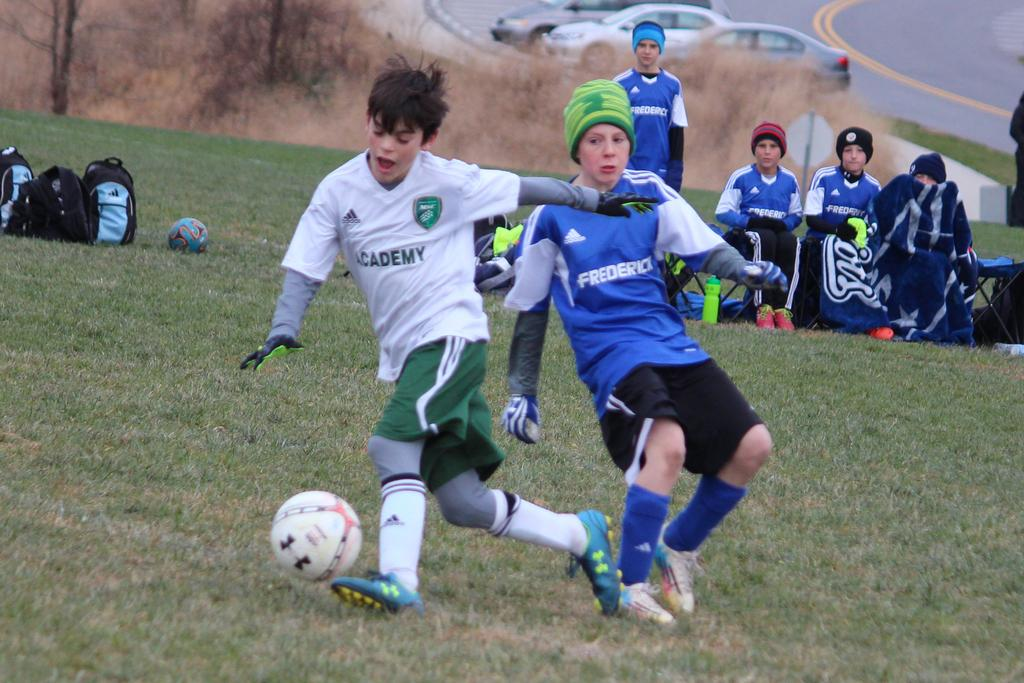Who is present in the image? There are people in the image. What activity are the people engaged in? The people are playing football. Where is the football game taking place? The football game is taking place on the ground. What else can be seen in the image besides the people playing football? There are bags and cars visible in the image. What type of notebook is being used to keep score during the football game? There is no notebook present in the image, and no mention of keeping score. 